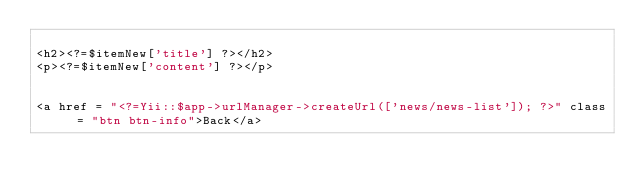<code> <loc_0><loc_0><loc_500><loc_500><_PHP_>
<h2><?=$itemNew['title'] ?></h2>
<p><?=$itemNew['content'] ?></p>


<a href = "<?=Yii::$app->urlManager->createUrl(['news/news-list']); ?>" class = "btn btn-info">Back</a></code> 